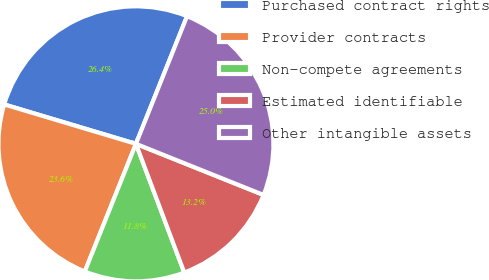Convert chart to OTSL. <chart><loc_0><loc_0><loc_500><loc_500><pie_chart><fcel>Purchased contract rights<fcel>Provider contracts<fcel>Non-compete agreements<fcel>Estimated identifiable<fcel>Other intangible assets<nl><fcel>26.44%<fcel>23.56%<fcel>11.78%<fcel>13.22%<fcel>25.0%<nl></chart> 